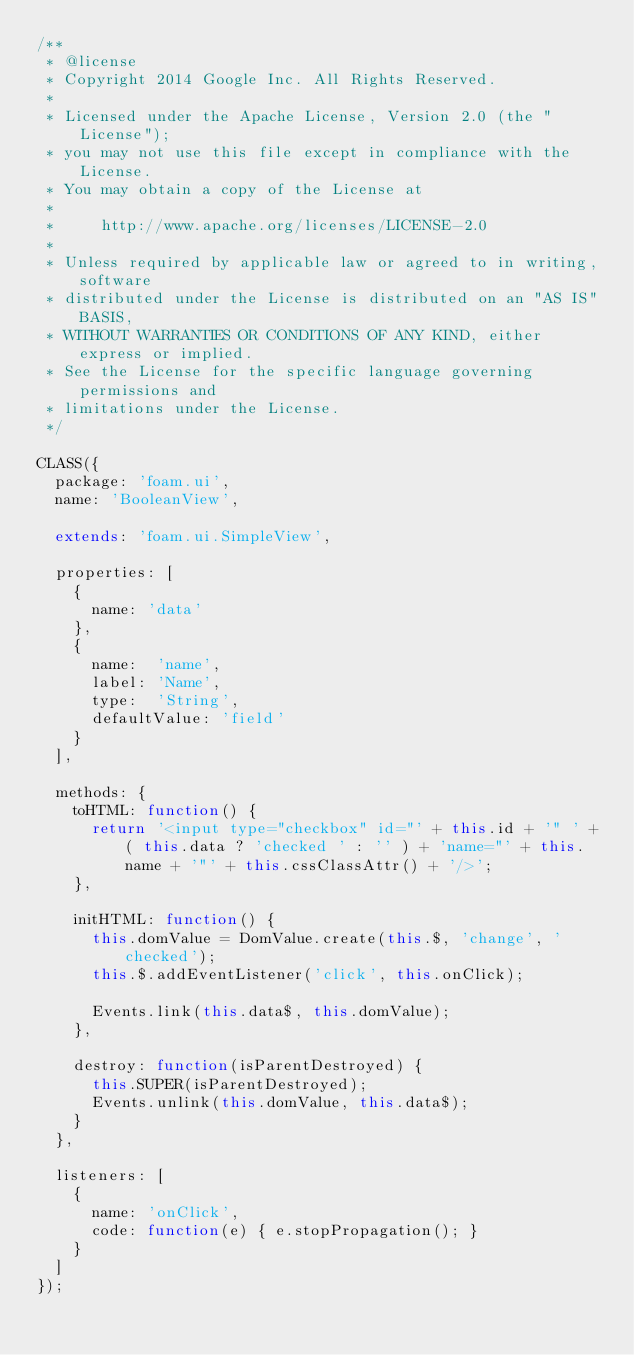<code> <loc_0><loc_0><loc_500><loc_500><_JavaScript_>/**
 * @license
 * Copyright 2014 Google Inc. All Rights Reserved.
 *
 * Licensed under the Apache License, Version 2.0 (the "License");
 * you may not use this file except in compliance with the License.
 * You may obtain a copy of the License at
 *
 *     http://www.apache.org/licenses/LICENSE-2.0
 *
 * Unless required by applicable law or agreed to in writing, software
 * distributed under the License is distributed on an "AS IS" BASIS,
 * WITHOUT WARRANTIES OR CONDITIONS OF ANY KIND, either express or implied.
 * See the License for the specific language governing permissions and
 * limitations under the License.
 */

CLASS({
  package: 'foam.ui',
  name: 'BooleanView',

  extends: 'foam.ui.SimpleView',

  properties: [
    {
      name: 'data'
    },
    {
      name:  'name',
      label: 'Name',
      type:  'String',
      defaultValue: 'field'
    }
  ],

  methods: {
    toHTML: function() {
      return '<input type="checkbox" id="' + this.id + '" ' + ( this.data ? 'checked ' : '' ) + 'name="' + this.name + '"' + this.cssClassAttr() + '/>';
    },

    initHTML: function() {
      this.domValue = DomValue.create(this.$, 'change', 'checked');
      this.$.addEventListener('click', this.onClick);

      Events.link(this.data$, this.domValue);
    },

    destroy: function(isParentDestroyed) {
      this.SUPER(isParentDestroyed);
      Events.unlink(this.domValue, this.data$);
    }
  },

  listeners: [
    {
      name: 'onClick',
      code: function(e) { e.stopPropagation(); }
    }
  ]
});
</code> 